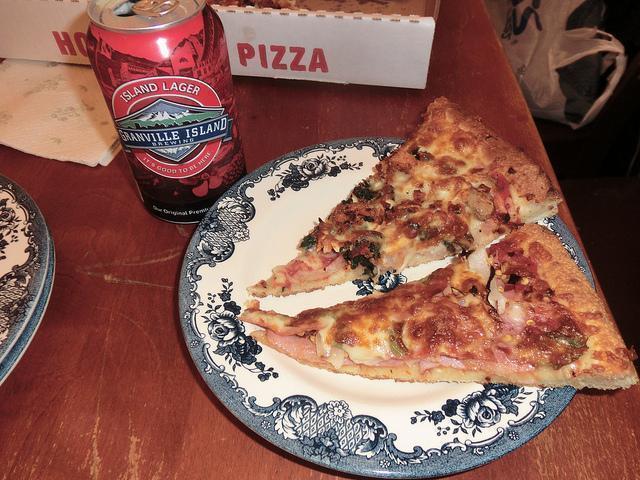What kind of beverage is being enjoyed with the pizza?
Make your selection and explain in format: 'Answer: answer
Rationale: rationale.'
Options: Soda, beer, vodka, juice. Answer: beer.
Rationale: The word lager can be seen on the can which is a type of beer. 